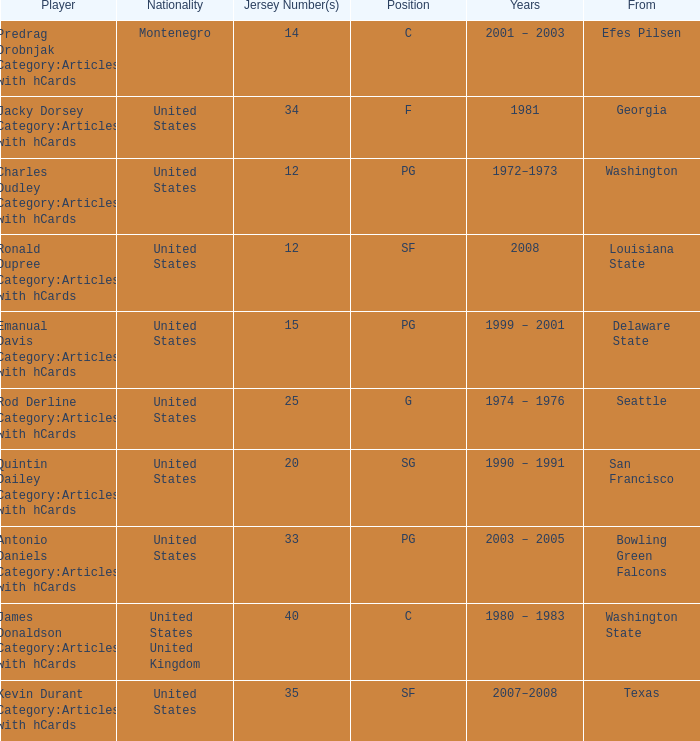What is the minimum jersey number assigned to a player from louisiana state? 12.0. 